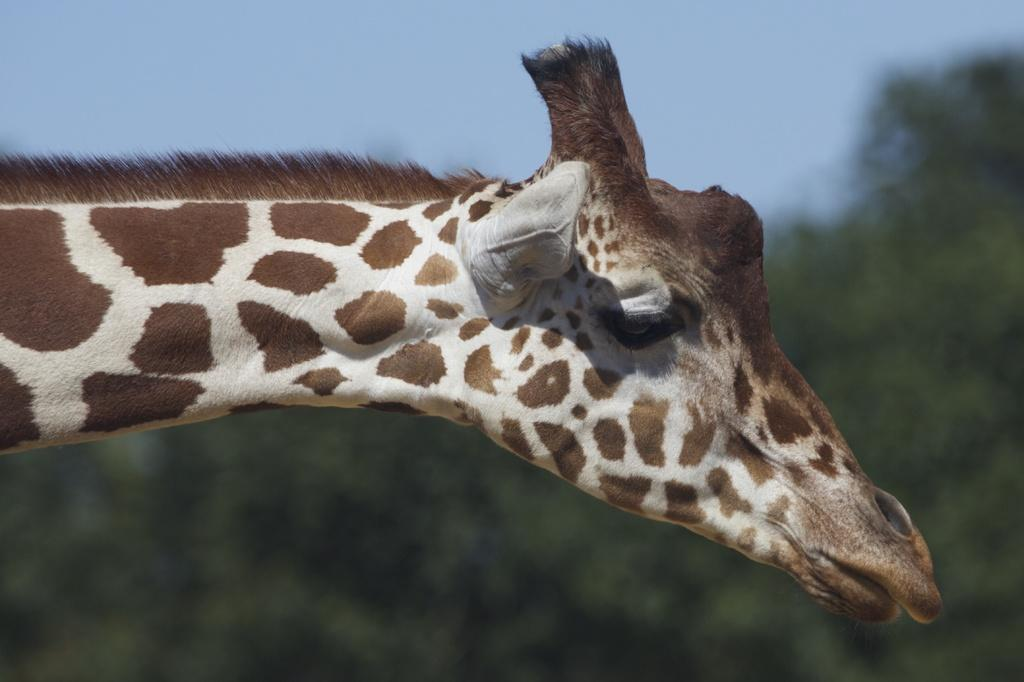What animal is the main subject of the picture? There is a giraffe in the picture. What can be seen in the background of the picture? There are trees in the background of the picture. What is the condition of the sky in the picture? The sky is clear in the picture. Can you tell me how many chess pieces are on the ground in the image? There are no chess pieces present in the image; it features a giraffe and trees in the background. Is there a chain hanging from the giraffe's neck in the image? There is no chain visible on the giraffe in the image. 